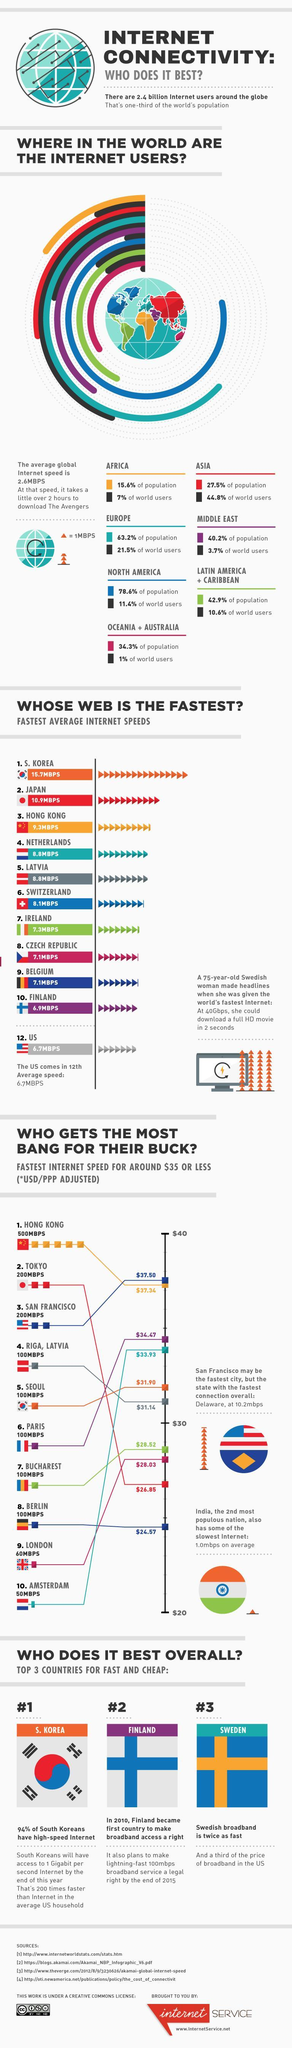How much do Amsterdam residents pay for 50MBPS internet speed in dollars?
Answer the question with a short phrase. $33.93 Which cities have more than 100 MBPS of internet speed? Hong Kong, Tokyo, San Francisco Which city has the lowest internet speed and fourth highest internet charges? Amsterdam Which continent has the highest percentage of internet users in the world? Europe What is the lowest percentage of internet users in the world ? 1% How many cities pay less than $30 as internet charges? 4 What is the highest percentage of population in the world? 78.6% Which continent contributes to the lowest population percentage in the world? Africa Which city has the second highest internet speed and second lowest internet charges? Tokyo 